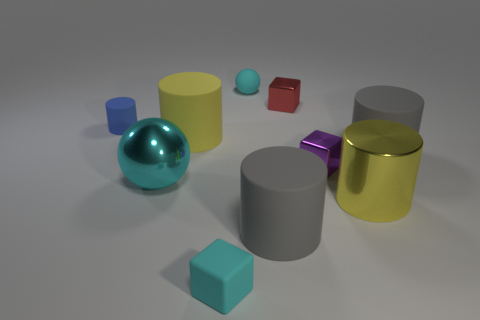What is the material of the objects in the image? The objects in the image seem to have a glossy finish, suggesting that they could be made of plastic or metal with a reflective coating to simulate such an appearance. 